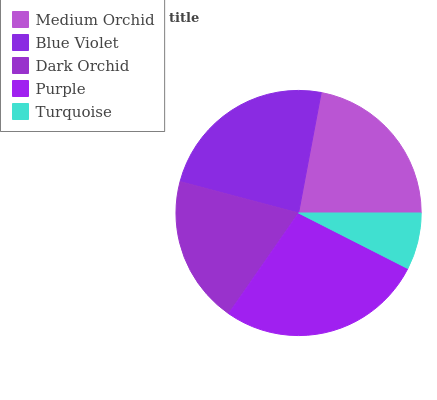Is Turquoise the minimum?
Answer yes or no. Yes. Is Purple the maximum?
Answer yes or no. Yes. Is Blue Violet the minimum?
Answer yes or no. No. Is Blue Violet the maximum?
Answer yes or no. No. Is Blue Violet greater than Medium Orchid?
Answer yes or no. Yes. Is Medium Orchid less than Blue Violet?
Answer yes or no. Yes. Is Medium Orchid greater than Blue Violet?
Answer yes or no. No. Is Blue Violet less than Medium Orchid?
Answer yes or no. No. Is Medium Orchid the high median?
Answer yes or no. Yes. Is Medium Orchid the low median?
Answer yes or no. Yes. Is Dark Orchid the high median?
Answer yes or no. No. Is Blue Violet the low median?
Answer yes or no. No. 